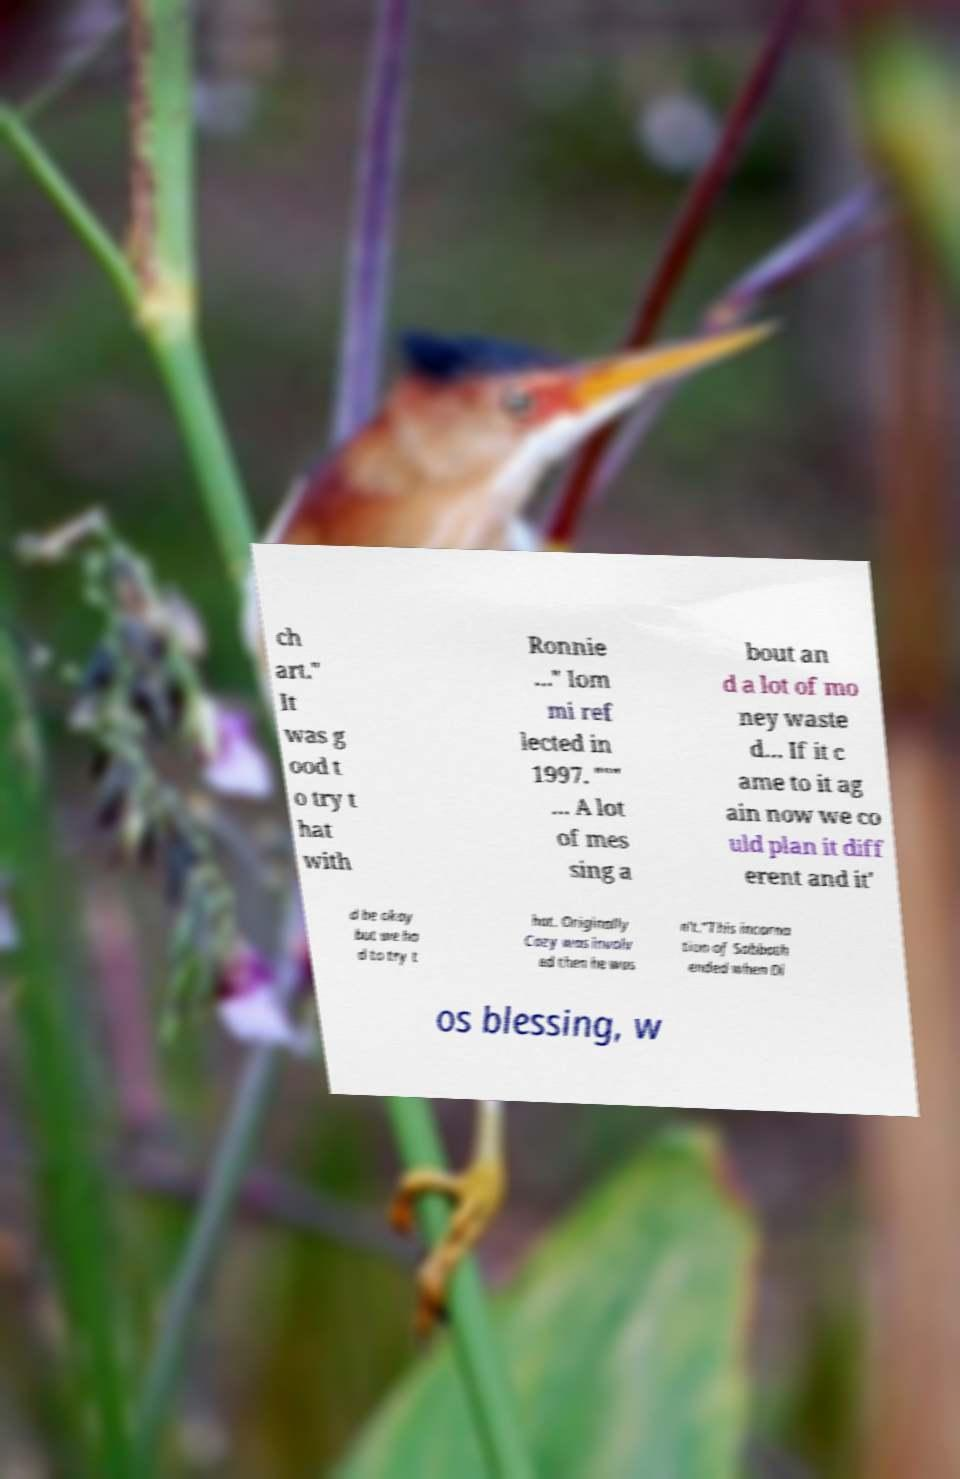Could you extract and type out the text from this image? ch art." It was g ood t o try t hat with Ronnie …" Iom mi ref lected in 1997. """ … A lot of mes sing a bout an d a lot of mo ney waste d… If it c ame to it ag ain now we co uld plan it diff erent and it' d be okay but we ha d to try t hat. Originally Cozy was involv ed then he was n't."This incarna tion of Sabbath ended when Di os blessing, w 